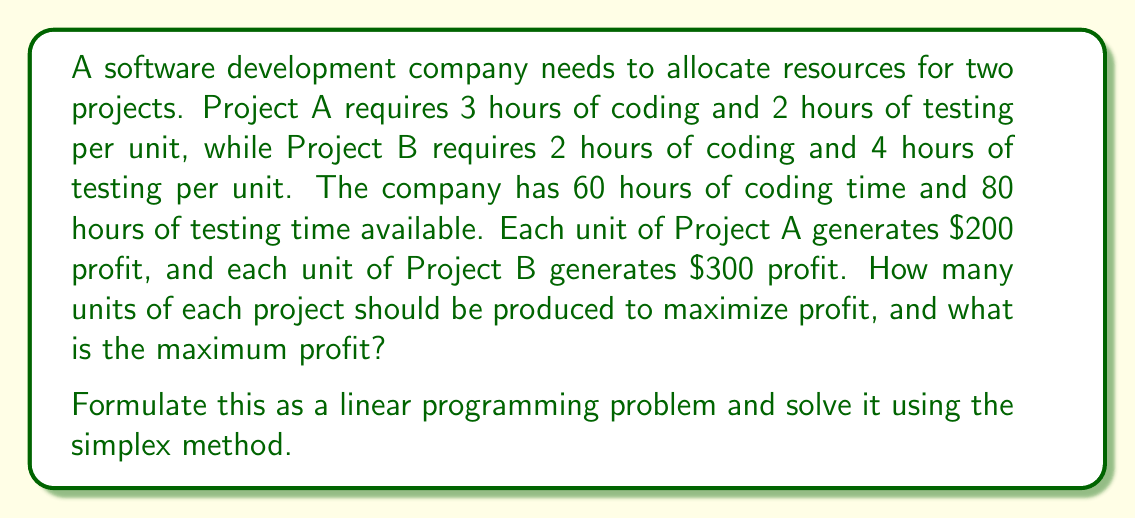Give your solution to this math problem. Let's approach this step-by-step:

1. Define variables:
   Let $x$ be the number of units of Project A
   Let $y$ be the number of units of Project B

2. Formulate the objective function:
   Maximize $Z = 200x + 300y$

3. Identify constraints:
   Coding time: $3x + 2y \leq 60$
   Testing time: $2x + 4y \leq 80$
   Non-negativity: $x \geq 0, y \geq 0$

4. Set up the initial simplex tableau:
   $$
   \begin{array}{c|cccccc}
    & x & y & s_1 & s_2 & \text{RHS} \\
   \hline
   s_1 & 3 & 2 & 1 & 0 & 60 \\
   s_2 & 2 & 4 & 0 & 1 & 80 \\
   \hline
   Z & -200 & -300 & 0 & 0 & 0
   \end{array}
   $$

5. Identify the pivot column (most negative in Z row): $y$ (-300)

6. Calculate ratios for the pivot row:
   $60/2 = 30$ for $s_1$
   $80/4 = 20$ for $s_2$
   Choose $s_2$ (smallest ratio)

7. Perform row operations to get:
   $$
   \begin{array}{c|cccccc}
    & x & y & s_1 & s_2 & \text{RHS} \\
   \hline
   s_1 & 2 & 0 & 1 & -1/2 & 20 \\
   y & 1/2 & 1 & 0 & 1/4 & 20 \\
   \hline
   Z & -50 & 0 & 0 & 75 & 6000
   \end{array}
   $$

8. Repeat steps 5-7:
   Pivot column: $x$
   Pivot row: $s_1$
   
   Final tableau:
   $$
   \begin{array}{c|cccccc}
    & x & y & s_1 & s_2 & \text{RHS} \\
   \hline
   x & 1 & 0 & 1/2 & -1/4 & 10 \\
   y & 0 & 1 & -1/4 & 3/8 & 15 \\
   \hline
   Z & 0 & 0 & 25 & 62.5 & 6500
   \end{array}
   $$

9. Read the solution:
   $x = 10$ (units of Project A)
   $y = 15$ (units of Project B)
   Maximum profit $Z = 6500$
Answer: 10 units of Project A, 15 units of Project B; Maximum profit $6500 